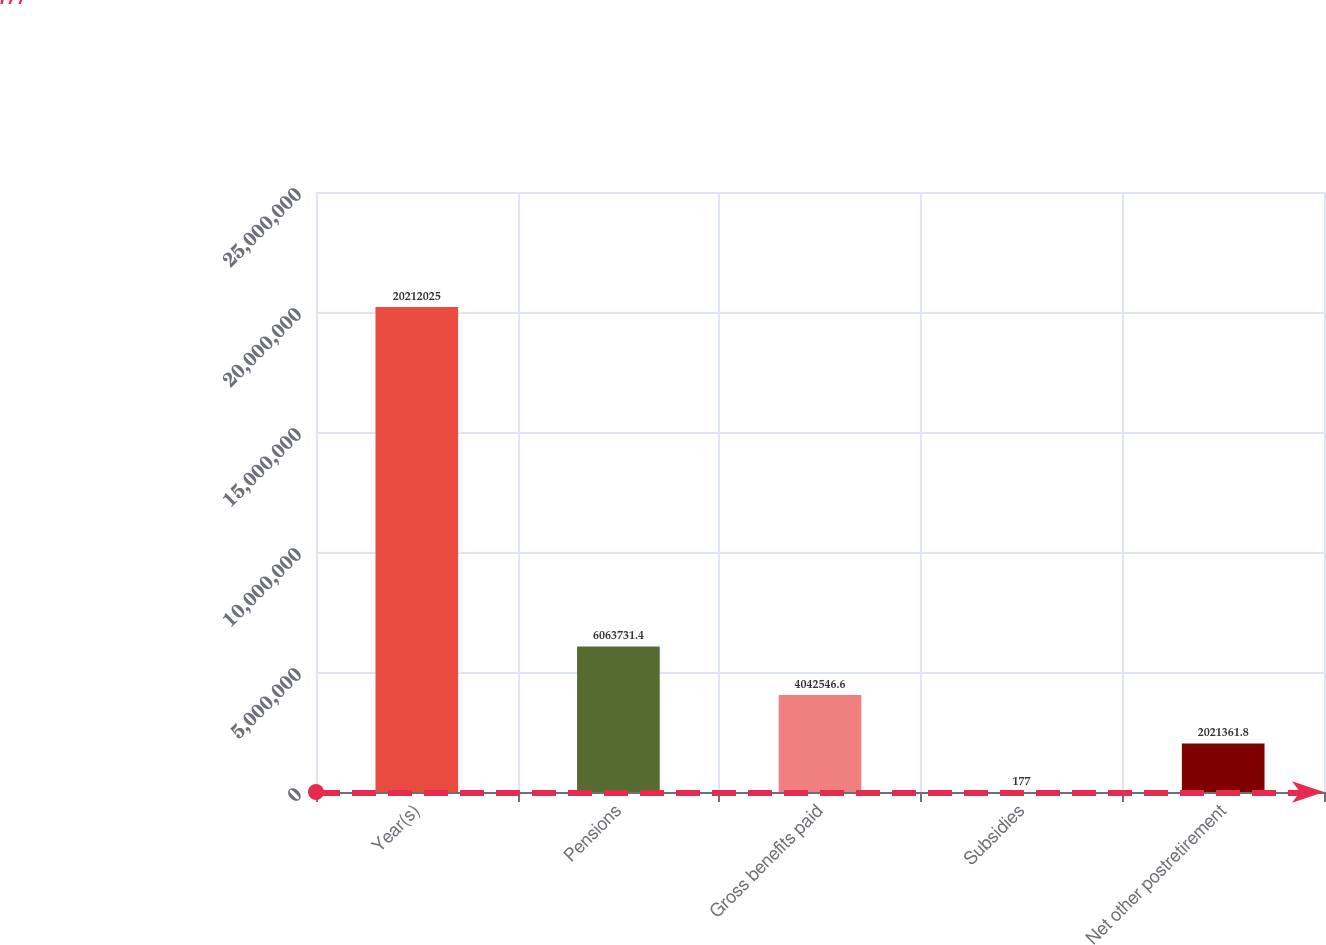<chart> <loc_0><loc_0><loc_500><loc_500><bar_chart><fcel>Year(s)<fcel>Pensions<fcel>Gross benefits paid<fcel>Subsidies<fcel>Net other postretirement<nl><fcel>2.0212e+07<fcel>6.06373e+06<fcel>4.04255e+06<fcel>177<fcel>2.02136e+06<nl></chart> 